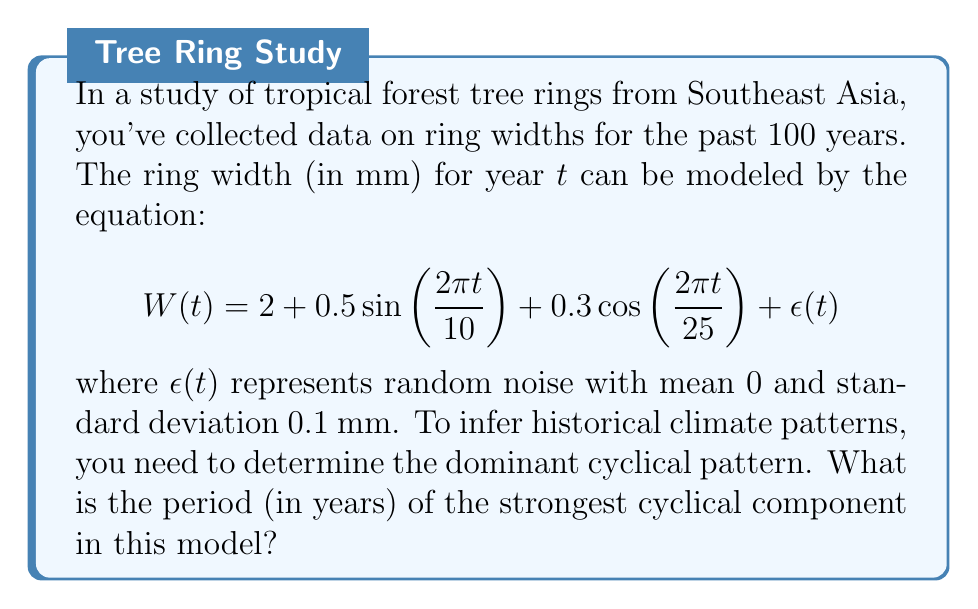Could you help me with this problem? To determine the dominant cyclical pattern, we need to analyze the periodic components in the given equation:

1. The equation contains two periodic functions:
   a) $0.5 \sin(\frac{2\pi t}{10})$
   b) $0.3 \cos(\frac{2\pi t}{25})$

2. For a sinusoidal function of the form $\sin(\frac{2\pi t}{T})$ or $\cos(\frac{2\pi t}{T})$, the period is given by $T$.

3. For the first component:
   $0.5 \sin(\frac{2\pi t}{10})$
   The period is 10 years.

4. For the second component:
   $0.3 \cos(\frac{2\pi t}{25})$
   The period is 25 years.

5. To determine which cyclical component is stronger, we compare their amplitudes:
   a) The first component has an amplitude of 0.5
   b) The second component has an amplitude of 0.3

6. The component with the larger amplitude is the stronger cyclical component.

Therefore, the strongest cyclical component has an amplitude of 0.5 and a period of 10 years.
Answer: 10 years 